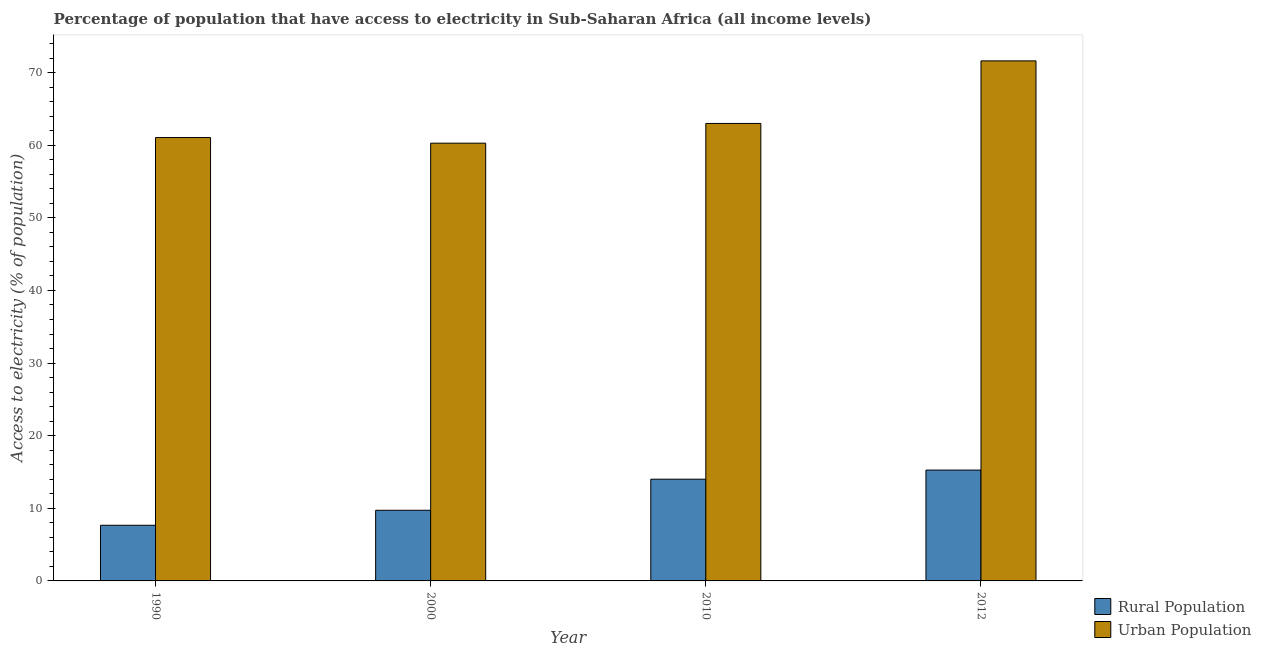How many different coloured bars are there?
Ensure brevity in your answer.  2. Are the number of bars per tick equal to the number of legend labels?
Offer a very short reply. Yes. How many bars are there on the 3rd tick from the left?
Your answer should be compact. 2. How many bars are there on the 3rd tick from the right?
Your response must be concise. 2. What is the percentage of urban population having access to electricity in 2010?
Give a very brief answer. 62.99. Across all years, what is the maximum percentage of rural population having access to electricity?
Make the answer very short. 15.27. Across all years, what is the minimum percentage of rural population having access to electricity?
Your answer should be compact. 7.66. In which year was the percentage of rural population having access to electricity minimum?
Offer a very short reply. 1990. What is the total percentage of rural population having access to electricity in the graph?
Offer a terse response. 46.66. What is the difference between the percentage of urban population having access to electricity in 1990 and that in 2000?
Provide a short and direct response. 0.78. What is the difference between the percentage of urban population having access to electricity in 2000 and the percentage of rural population having access to electricity in 2010?
Provide a short and direct response. -2.72. What is the average percentage of rural population having access to electricity per year?
Your response must be concise. 11.67. What is the ratio of the percentage of rural population having access to electricity in 2000 to that in 2010?
Offer a terse response. 0.69. Is the difference between the percentage of rural population having access to electricity in 1990 and 2010 greater than the difference between the percentage of urban population having access to electricity in 1990 and 2010?
Offer a terse response. No. What is the difference between the highest and the second highest percentage of rural population having access to electricity?
Ensure brevity in your answer.  1.26. What is the difference between the highest and the lowest percentage of rural population having access to electricity?
Keep it short and to the point. 7.6. What does the 1st bar from the left in 2012 represents?
Make the answer very short. Rural Population. What does the 1st bar from the right in 2010 represents?
Your answer should be compact. Urban Population. How many bars are there?
Offer a terse response. 8. Does the graph contain any zero values?
Ensure brevity in your answer.  No. How are the legend labels stacked?
Provide a succinct answer. Vertical. What is the title of the graph?
Your response must be concise. Percentage of population that have access to electricity in Sub-Saharan Africa (all income levels). Does "From human activities" appear as one of the legend labels in the graph?
Provide a short and direct response. No. What is the label or title of the X-axis?
Offer a very short reply. Year. What is the label or title of the Y-axis?
Ensure brevity in your answer.  Access to electricity (% of population). What is the Access to electricity (% of population) in Rural Population in 1990?
Make the answer very short. 7.66. What is the Access to electricity (% of population) in Urban Population in 1990?
Offer a very short reply. 61.05. What is the Access to electricity (% of population) of Rural Population in 2000?
Ensure brevity in your answer.  9.73. What is the Access to electricity (% of population) in Urban Population in 2000?
Provide a short and direct response. 60.28. What is the Access to electricity (% of population) in Rural Population in 2010?
Your answer should be very brief. 14.01. What is the Access to electricity (% of population) of Urban Population in 2010?
Your answer should be very brief. 62.99. What is the Access to electricity (% of population) of Rural Population in 2012?
Provide a succinct answer. 15.27. What is the Access to electricity (% of population) of Urban Population in 2012?
Offer a very short reply. 71.61. Across all years, what is the maximum Access to electricity (% of population) of Rural Population?
Provide a succinct answer. 15.27. Across all years, what is the maximum Access to electricity (% of population) of Urban Population?
Provide a short and direct response. 71.61. Across all years, what is the minimum Access to electricity (% of population) of Rural Population?
Your answer should be very brief. 7.66. Across all years, what is the minimum Access to electricity (% of population) in Urban Population?
Your answer should be compact. 60.28. What is the total Access to electricity (% of population) of Rural Population in the graph?
Offer a terse response. 46.66. What is the total Access to electricity (% of population) of Urban Population in the graph?
Make the answer very short. 255.94. What is the difference between the Access to electricity (% of population) of Rural Population in 1990 and that in 2000?
Offer a very short reply. -2.07. What is the difference between the Access to electricity (% of population) of Urban Population in 1990 and that in 2000?
Ensure brevity in your answer.  0.78. What is the difference between the Access to electricity (% of population) in Rural Population in 1990 and that in 2010?
Your answer should be compact. -6.35. What is the difference between the Access to electricity (% of population) of Urban Population in 1990 and that in 2010?
Your response must be concise. -1.94. What is the difference between the Access to electricity (% of population) of Rural Population in 1990 and that in 2012?
Your answer should be compact. -7.6. What is the difference between the Access to electricity (% of population) of Urban Population in 1990 and that in 2012?
Your answer should be compact. -10.56. What is the difference between the Access to electricity (% of population) of Rural Population in 2000 and that in 2010?
Make the answer very short. -4.28. What is the difference between the Access to electricity (% of population) of Urban Population in 2000 and that in 2010?
Provide a short and direct response. -2.72. What is the difference between the Access to electricity (% of population) in Rural Population in 2000 and that in 2012?
Your answer should be compact. -5.54. What is the difference between the Access to electricity (% of population) in Urban Population in 2000 and that in 2012?
Offer a terse response. -11.33. What is the difference between the Access to electricity (% of population) of Rural Population in 2010 and that in 2012?
Your answer should be very brief. -1.26. What is the difference between the Access to electricity (% of population) of Urban Population in 2010 and that in 2012?
Offer a terse response. -8.62. What is the difference between the Access to electricity (% of population) in Rural Population in 1990 and the Access to electricity (% of population) in Urban Population in 2000?
Your response must be concise. -52.62. What is the difference between the Access to electricity (% of population) of Rural Population in 1990 and the Access to electricity (% of population) of Urban Population in 2010?
Provide a short and direct response. -55.33. What is the difference between the Access to electricity (% of population) of Rural Population in 1990 and the Access to electricity (% of population) of Urban Population in 2012?
Offer a terse response. -63.95. What is the difference between the Access to electricity (% of population) of Rural Population in 2000 and the Access to electricity (% of population) of Urban Population in 2010?
Offer a very short reply. -53.27. What is the difference between the Access to electricity (% of population) of Rural Population in 2000 and the Access to electricity (% of population) of Urban Population in 2012?
Your response must be concise. -61.88. What is the difference between the Access to electricity (% of population) in Rural Population in 2010 and the Access to electricity (% of population) in Urban Population in 2012?
Make the answer very short. -57.6. What is the average Access to electricity (% of population) in Rural Population per year?
Make the answer very short. 11.67. What is the average Access to electricity (% of population) in Urban Population per year?
Offer a very short reply. 63.98. In the year 1990, what is the difference between the Access to electricity (% of population) of Rural Population and Access to electricity (% of population) of Urban Population?
Provide a succinct answer. -53.39. In the year 2000, what is the difference between the Access to electricity (% of population) in Rural Population and Access to electricity (% of population) in Urban Population?
Offer a terse response. -50.55. In the year 2010, what is the difference between the Access to electricity (% of population) of Rural Population and Access to electricity (% of population) of Urban Population?
Offer a very short reply. -48.99. In the year 2012, what is the difference between the Access to electricity (% of population) in Rural Population and Access to electricity (% of population) in Urban Population?
Your response must be concise. -56.35. What is the ratio of the Access to electricity (% of population) of Rural Population in 1990 to that in 2000?
Your answer should be very brief. 0.79. What is the ratio of the Access to electricity (% of population) in Urban Population in 1990 to that in 2000?
Your answer should be very brief. 1.01. What is the ratio of the Access to electricity (% of population) in Rural Population in 1990 to that in 2010?
Give a very brief answer. 0.55. What is the ratio of the Access to electricity (% of population) of Urban Population in 1990 to that in 2010?
Offer a very short reply. 0.97. What is the ratio of the Access to electricity (% of population) in Rural Population in 1990 to that in 2012?
Make the answer very short. 0.5. What is the ratio of the Access to electricity (% of population) of Urban Population in 1990 to that in 2012?
Make the answer very short. 0.85. What is the ratio of the Access to electricity (% of population) of Rural Population in 2000 to that in 2010?
Make the answer very short. 0.69. What is the ratio of the Access to electricity (% of population) in Urban Population in 2000 to that in 2010?
Keep it short and to the point. 0.96. What is the ratio of the Access to electricity (% of population) in Rural Population in 2000 to that in 2012?
Offer a very short reply. 0.64. What is the ratio of the Access to electricity (% of population) in Urban Population in 2000 to that in 2012?
Provide a short and direct response. 0.84. What is the ratio of the Access to electricity (% of population) of Rural Population in 2010 to that in 2012?
Make the answer very short. 0.92. What is the ratio of the Access to electricity (% of population) of Urban Population in 2010 to that in 2012?
Give a very brief answer. 0.88. What is the difference between the highest and the second highest Access to electricity (% of population) in Rural Population?
Offer a very short reply. 1.26. What is the difference between the highest and the second highest Access to electricity (% of population) in Urban Population?
Make the answer very short. 8.62. What is the difference between the highest and the lowest Access to electricity (% of population) in Rural Population?
Give a very brief answer. 7.6. What is the difference between the highest and the lowest Access to electricity (% of population) of Urban Population?
Give a very brief answer. 11.33. 